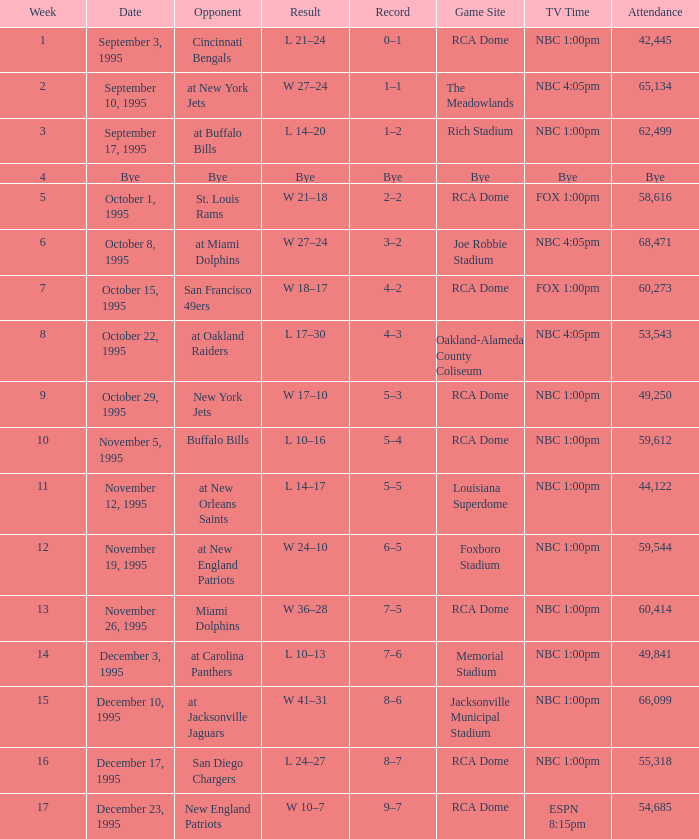What's the adversary with a week that's greater than 16? New England Patriots. 